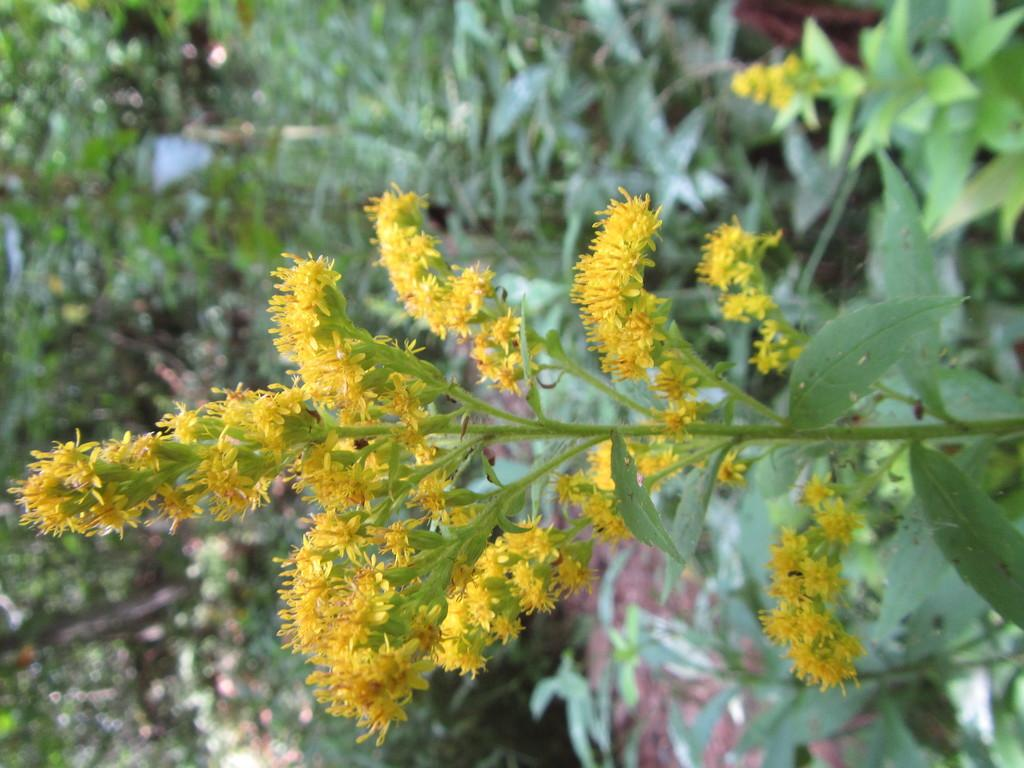What is the main subject of the image? There is a giant goldenrod plant in the image. Can you describe the other plants visible in the image? There are other plants in the background of the image. What type of cemetery can be seen in the image? There is no cemetery present in the image; it features a giant goldenrod plant and other plants in the background. How does the digestion process of the plants in the image work? The image does not provide information about the digestion process of the plants; it only shows their appearance. 